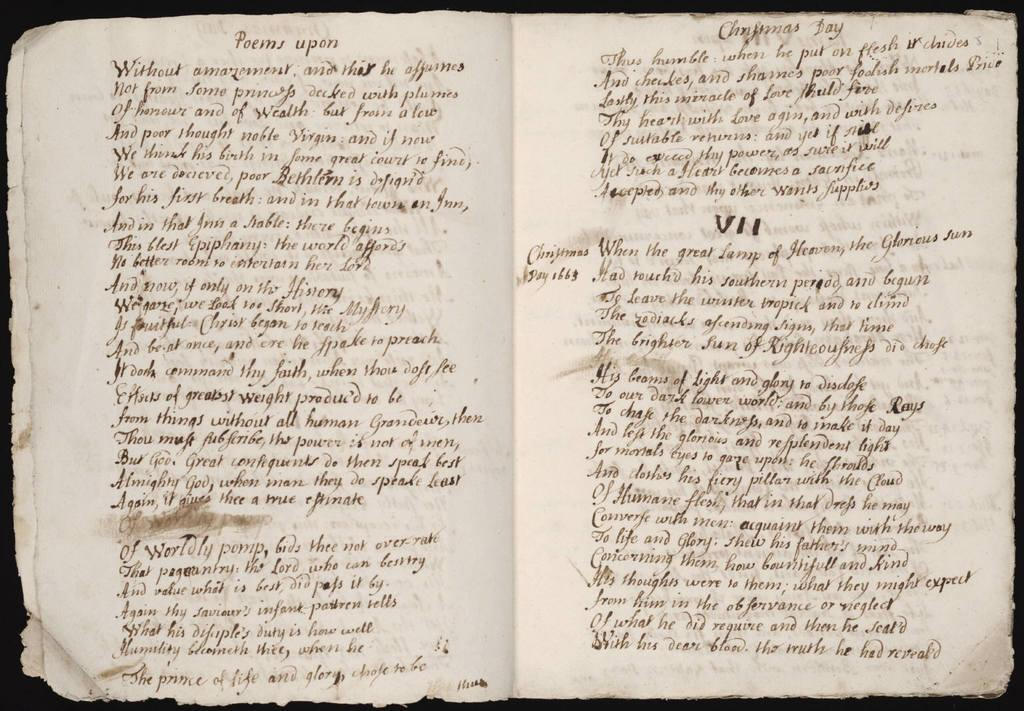Provide a one-sentence caption for the provided image. a handwritten book open to a page titled Poems upon. 